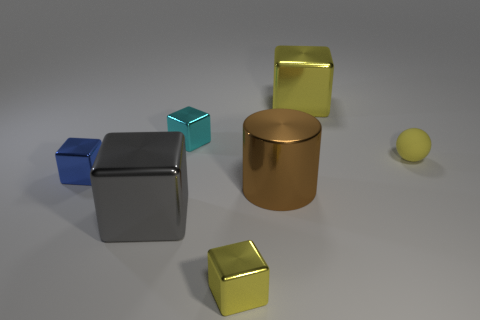How big is the metallic cube that is both in front of the yellow matte thing and behind the large gray shiny cube?
Provide a short and direct response. Small. Do the small blue thing and the cyan metallic object have the same shape?
Your answer should be very brief. Yes. There is a big yellow object that is the same material as the gray thing; what shape is it?
Keep it short and to the point. Cube. What number of tiny things are either gray blocks or metallic cylinders?
Offer a very short reply. 0. Are there any large shiny cylinders to the left of the big metallic block on the right side of the cyan metallic cube?
Provide a short and direct response. Yes. Is there a yellow metal object?
Keep it short and to the point. Yes. There is a ball behind the yellow shiny object that is to the left of the large yellow thing; what is its color?
Ensure brevity in your answer.  Yellow. What is the material of the large yellow thing that is the same shape as the small blue metal object?
Your answer should be compact. Metal. How many gray objects are the same size as the yellow ball?
Keep it short and to the point. 0. There is a cylinder that is made of the same material as the blue thing; what size is it?
Your response must be concise. Large. 